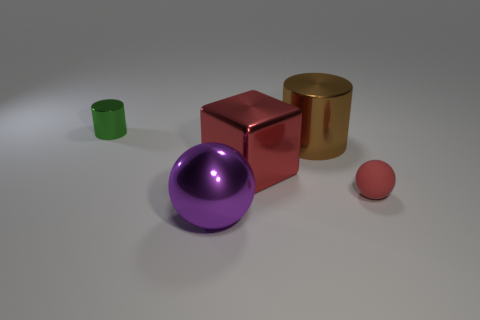Add 1 big shiny spheres. How many objects exist? 6 Subtract all spheres. How many objects are left? 3 Add 1 big objects. How many big objects exist? 4 Subtract 0 brown balls. How many objects are left? 5 Subtract all metal cylinders. Subtract all big red metal cylinders. How many objects are left? 3 Add 3 tiny balls. How many tiny balls are left? 4 